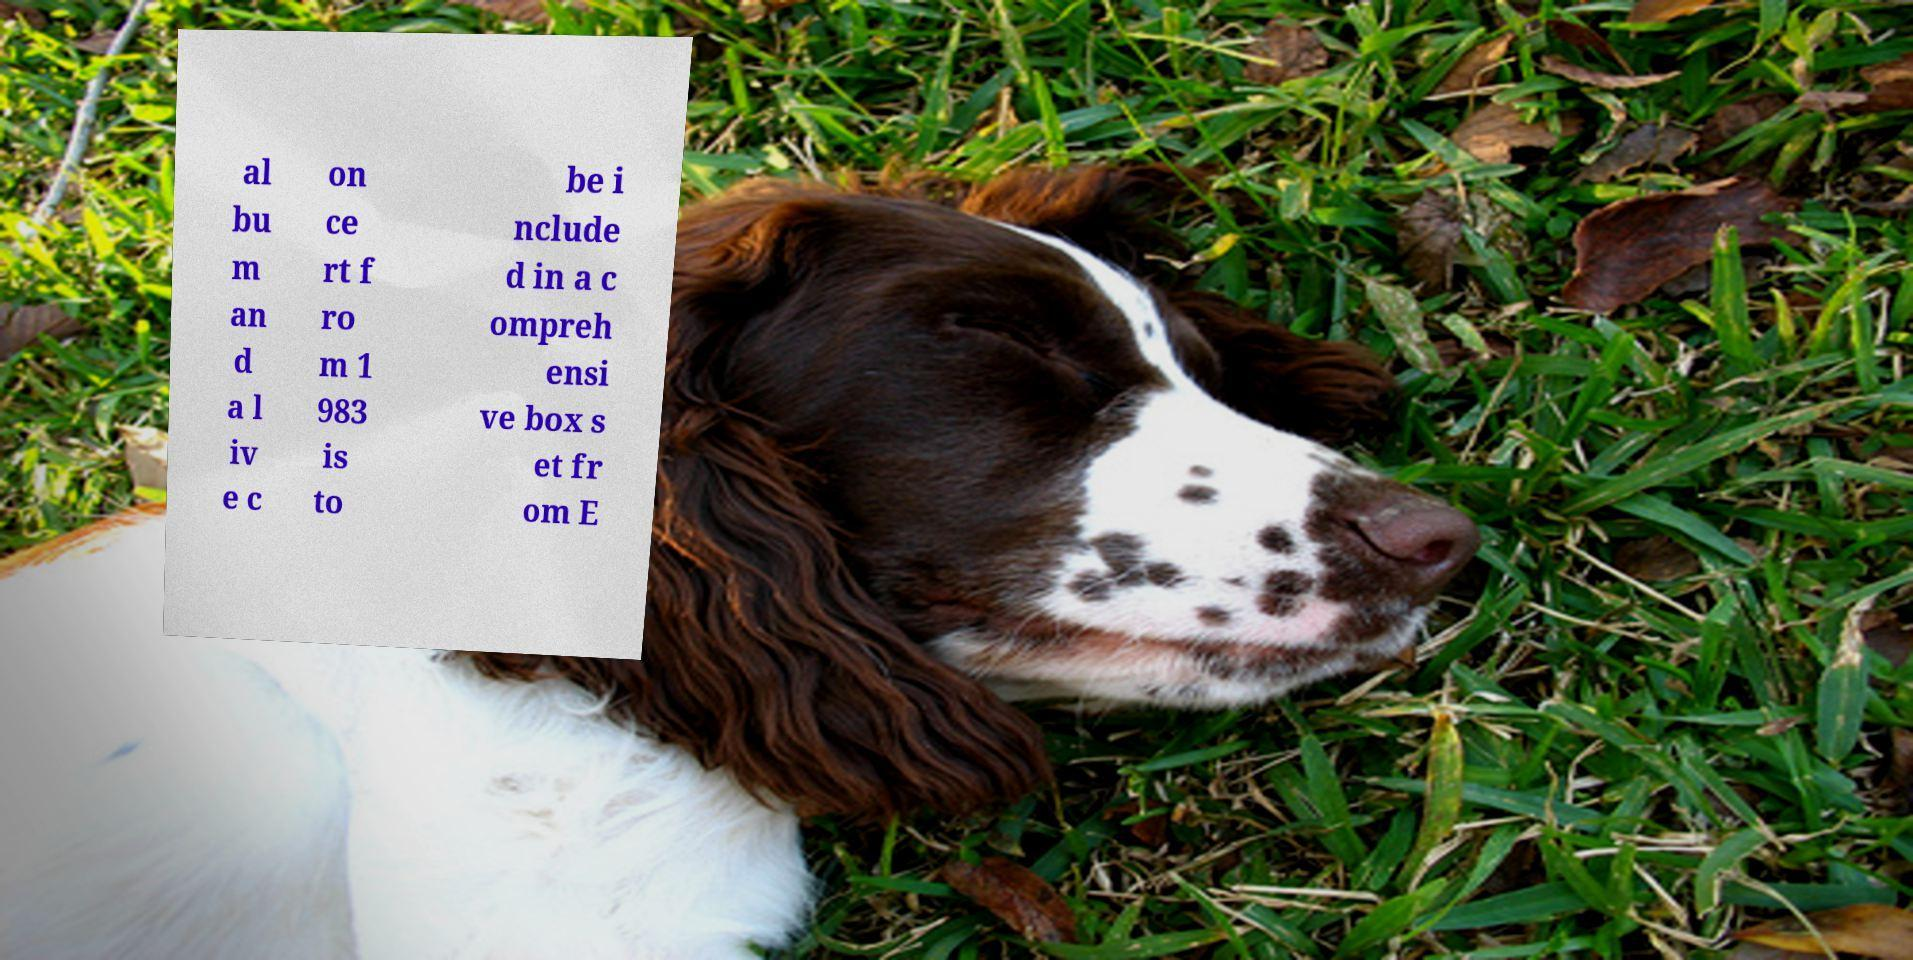Please identify and transcribe the text found in this image. al bu m an d a l iv e c on ce rt f ro m 1 983 is to be i nclude d in a c ompreh ensi ve box s et fr om E 